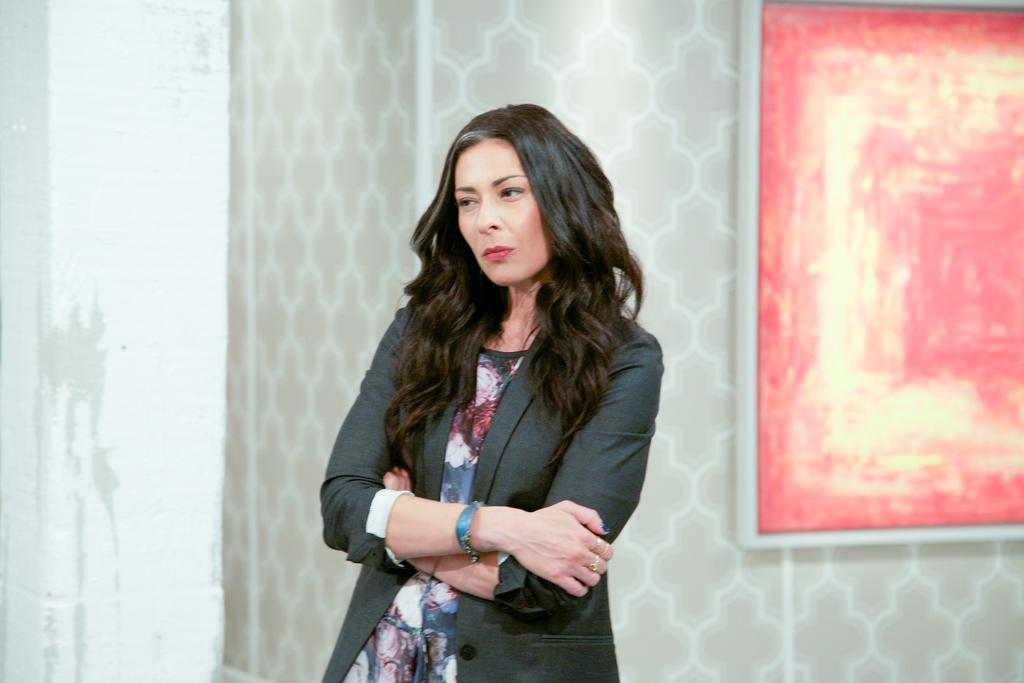How would you summarize this image in a sentence or two? In this picture we can see a woman standing. There is a frame on the wall on the right side. 